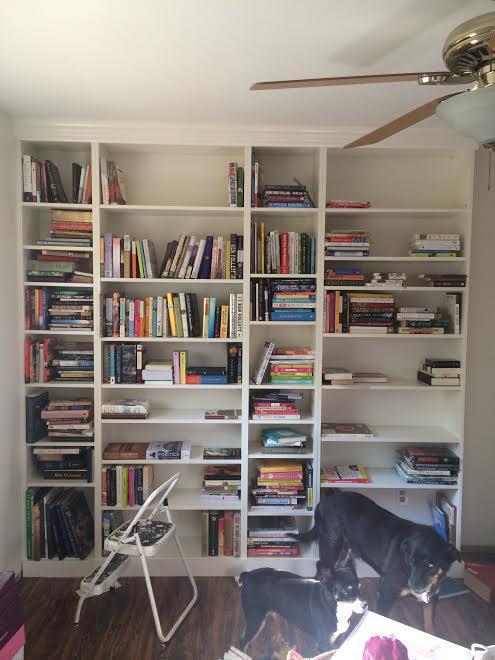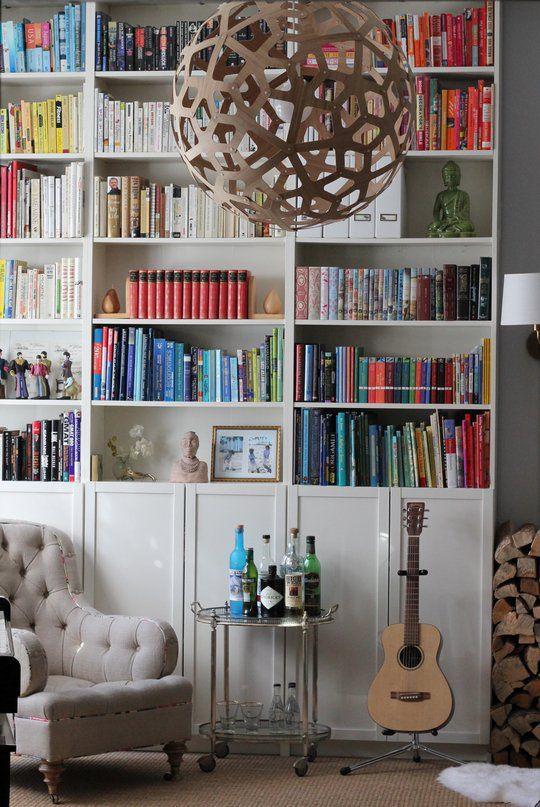The first image is the image on the left, the second image is the image on the right. Considering the images on both sides, is "An image contains a large white bookshelf with an acoustic guitar on a stand in front of it." valid? Answer yes or no. Yes. 